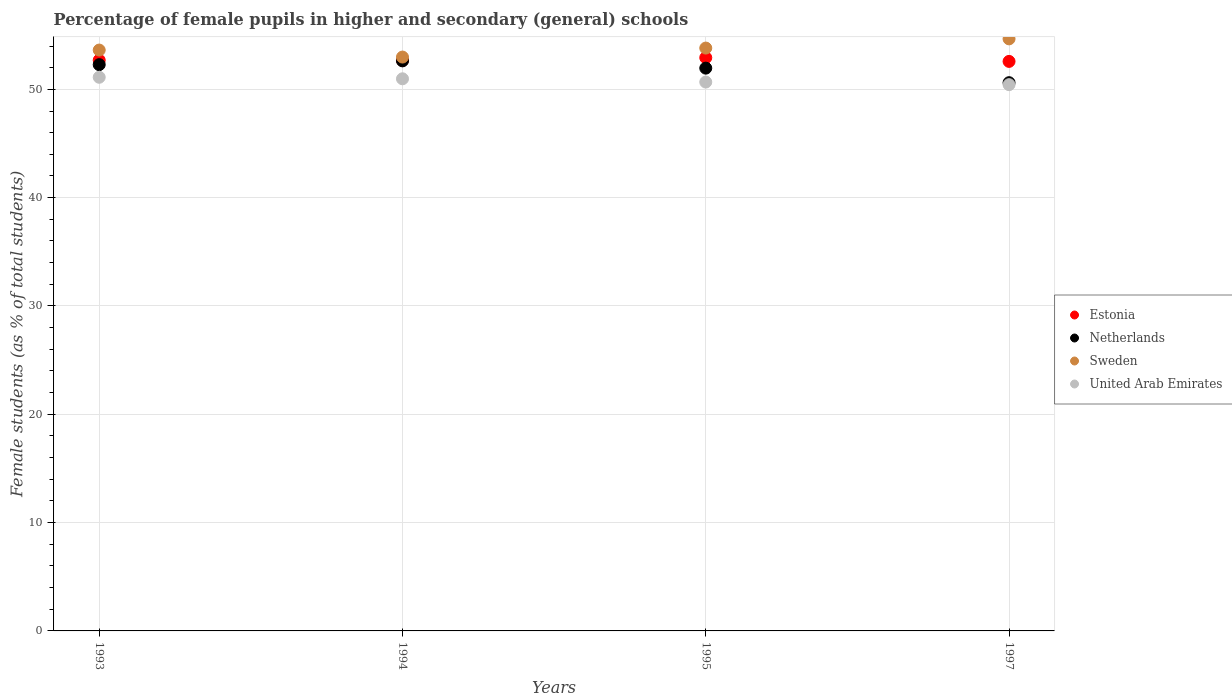Is the number of dotlines equal to the number of legend labels?
Make the answer very short. Yes. What is the percentage of female pupils in higher and secondary schools in Sweden in 1995?
Your answer should be compact. 53.81. Across all years, what is the maximum percentage of female pupils in higher and secondary schools in United Arab Emirates?
Offer a very short reply. 51.12. Across all years, what is the minimum percentage of female pupils in higher and secondary schools in Sweden?
Your answer should be compact. 52.98. In which year was the percentage of female pupils in higher and secondary schools in Sweden minimum?
Your answer should be very brief. 1994. What is the total percentage of female pupils in higher and secondary schools in Sweden in the graph?
Offer a very short reply. 215.08. What is the difference between the percentage of female pupils in higher and secondary schools in United Arab Emirates in 1994 and that in 1997?
Give a very brief answer. 0.54. What is the difference between the percentage of female pupils in higher and secondary schools in United Arab Emirates in 1993 and the percentage of female pupils in higher and secondary schools in Netherlands in 1995?
Ensure brevity in your answer.  -0.84. What is the average percentage of female pupils in higher and secondary schools in Estonia per year?
Make the answer very short. 52.72. In the year 1994, what is the difference between the percentage of female pupils in higher and secondary schools in Sweden and percentage of female pupils in higher and secondary schools in Estonia?
Provide a short and direct response. 0.3. What is the ratio of the percentage of female pupils in higher and secondary schools in Estonia in 1994 to that in 1997?
Make the answer very short. 1. Is the percentage of female pupils in higher and secondary schools in Estonia in 1993 less than that in 1994?
Ensure brevity in your answer.  No. Is the difference between the percentage of female pupils in higher and secondary schools in Sweden in 1993 and 1994 greater than the difference between the percentage of female pupils in higher and secondary schools in Estonia in 1993 and 1994?
Keep it short and to the point. Yes. What is the difference between the highest and the second highest percentage of female pupils in higher and secondary schools in Estonia?
Provide a succinct answer. 0.23. What is the difference between the highest and the lowest percentage of female pupils in higher and secondary schools in Sweden?
Your answer should be compact. 1.68. Is it the case that in every year, the sum of the percentage of female pupils in higher and secondary schools in Netherlands and percentage of female pupils in higher and secondary schools in Sweden  is greater than the sum of percentage of female pupils in higher and secondary schools in United Arab Emirates and percentage of female pupils in higher and secondary schools in Estonia?
Keep it short and to the point. No. Does the percentage of female pupils in higher and secondary schools in Netherlands monotonically increase over the years?
Offer a terse response. No. Is the percentage of female pupils in higher and secondary schools in Netherlands strictly greater than the percentage of female pupils in higher and secondary schools in United Arab Emirates over the years?
Provide a succinct answer. Yes. How many years are there in the graph?
Offer a very short reply. 4. What is the difference between two consecutive major ticks on the Y-axis?
Provide a succinct answer. 10. Are the values on the major ticks of Y-axis written in scientific E-notation?
Give a very brief answer. No. Does the graph contain any zero values?
Make the answer very short. No. Does the graph contain grids?
Your answer should be compact. Yes. Where does the legend appear in the graph?
Your answer should be very brief. Center right. What is the title of the graph?
Give a very brief answer. Percentage of female pupils in higher and secondary (general) schools. Does "Greenland" appear as one of the legend labels in the graph?
Keep it short and to the point. No. What is the label or title of the Y-axis?
Offer a terse response. Female students (as % of total students). What is the Female students (as % of total students) of Estonia in 1993?
Provide a short and direct response. 52.69. What is the Female students (as % of total students) of Netherlands in 1993?
Your answer should be compact. 52.28. What is the Female students (as % of total students) in Sweden in 1993?
Your answer should be compact. 53.63. What is the Female students (as % of total students) of United Arab Emirates in 1993?
Your answer should be compact. 51.12. What is the Female students (as % of total students) in Estonia in 1994?
Give a very brief answer. 52.68. What is the Female students (as % of total students) in Netherlands in 1994?
Ensure brevity in your answer.  52.63. What is the Female students (as % of total students) in Sweden in 1994?
Offer a terse response. 52.98. What is the Female students (as % of total students) in United Arab Emirates in 1994?
Offer a very short reply. 50.97. What is the Female students (as % of total students) in Estonia in 1995?
Your answer should be compact. 52.93. What is the Female students (as % of total students) of Netherlands in 1995?
Give a very brief answer. 51.96. What is the Female students (as % of total students) of Sweden in 1995?
Offer a very short reply. 53.81. What is the Female students (as % of total students) in United Arab Emirates in 1995?
Your answer should be compact. 50.67. What is the Female students (as % of total students) of Estonia in 1997?
Give a very brief answer. 52.58. What is the Female students (as % of total students) in Netherlands in 1997?
Provide a succinct answer. 50.62. What is the Female students (as % of total students) in Sweden in 1997?
Your response must be concise. 54.66. What is the Female students (as % of total students) of United Arab Emirates in 1997?
Offer a very short reply. 50.43. Across all years, what is the maximum Female students (as % of total students) of Estonia?
Keep it short and to the point. 52.93. Across all years, what is the maximum Female students (as % of total students) of Netherlands?
Provide a short and direct response. 52.63. Across all years, what is the maximum Female students (as % of total students) of Sweden?
Offer a terse response. 54.66. Across all years, what is the maximum Female students (as % of total students) of United Arab Emirates?
Offer a very short reply. 51.12. Across all years, what is the minimum Female students (as % of total students) of Estonia?
Offer a very short reply. 52.58. Across all years, what is the minimum Female students (as % of total students) of Netherlands?
Keep it short and to the point. 50.62. Across all years, what is the minimum Female students (as % of total students) of Sweden?
Keep it short and to the point. 52.98. Across all years, what is the minimum Female students (as % of total students) in United Arab Emirates?
Your response must be concise. 50.43. What is the total Female students (as % of total students) of Estonia in the graph?
Offer a terse response. 210.87. What is the total Female students (as % of total students) in Netherlands in the graph?
Provide a short and direct response. 207.48. What is the total Female students (as % of total students) in Sweden in the graph?
Offer a terse response. 215.08. What is the total Female students (as % of total students) in United Arab Emirates in the graph?
Your answer should be compact. 203.2. What is the difference between the Female students (as % of total students) of Estonia in 1993 and that in 1994?
Offer a very short reply. 0.01. What is the difference between the Female students (as % of total students) of Netherlands in 1993 and that in 1994?
Give a very brief answer. -0.35. What is the difference between the Female students (as % of total students) of Sweden in 1993 and that in 1994?
Make the answer very short. 0.65. What is the difference between the Female students (as % of total students) of United Arab Emirates in 1993 and that in 1994?
Make the answer very short. 0.14. What is the difference between the Female students (as % of total students) of Estonia in 1993 and that in 1995?
Ensure brevity in your answer.  -0.23. What is the difference between the Female students (as % of total students) in Netherlands in 1993 and that in 1995?
Ensure brevity in your answer.  0.32. What is the difference between the Female students (as % of total students) in Sweden in 1993 and that in 1995?
Offer a very short reply. -0.18. What is the difference between the Female students (as % of total students) of United Arab Emirates in 1993 and that in 1995?
Provide a succinct answer. 0.44. What is the difference between the Female students (as % of total students) of Estonia in 1993 and that in 1997?
Provide a short and direct response. 0.11. What is the difference between the Female students (as % of total students) of Netherlands in 1993 and that in 1997?
Give a very brief answer. 1.67. What is the difference between the Female students (as % of total students) in Sweden in 1993 and that in 1997?
Keep it short and to the point. -1.03. What is the difference between the Female students (as % of total students) in United Arab Emirates in 1993 and that in 1997?
Offer a very short reply. 0.68. What is the difference between the Female students (as % of total students) of Estonia in 1994 and that in 1995?
Ensure brevity in your answer.  -0.25. What is the difference between the Female students (as % of total students) of Netherlands in 1994 and that in 1995?
Your answer should be compact. 0.67. What is the difference between the Female students (as % of total students) in Sweden in 1994 and that in 1995?
Your answer should be compact. -0.83. What is the difference between the Female students (as % of total students) of United Arab Emirates in 1994 and that in 1995?
Offer a very short reply. 0.3. What is the difference between the Female students (as % of total students) of Estonia in 1994 and that in 1997?
Offer a very short reply. 0.1. What is the difference between the Female students (as % of total students) of Netherlands in 1994 and that in 1997?
Ensure brevity in your answer.  2.01. What is the difference between the Female students (as % of total students) of Sweden in 1994 and that in 1997?
Your answer should be compact. -1.68. What is the difference between the Female students (as % of total students) in United Arab Emirates in 1994 and that in 1997?
Your answer should be very brief. 0.54. What is the difference between the Female students (as % of total students) of Estonia in 1995 and that in 1997?
Give a very brief answer. 0.35. What is the difference between the Female students (as % of total students) in Netherlands in 1995 and that in 1997?
Your response must be concise. 1.34. What is the difference between the Female students (as % of total students) of Sweden in 1995 and that in 1997?
Your answer should be very brief. -0.85. What is the difference between the Female students (as % of total students) of United Arab Emirates in 1995 and that in 1997?
Your answer should be very brief. 0.24. What is the difference between the Female students (as % of total students) in Estonia in 1993 and the Female students (as % of total students) in Netherlands in 1994?
Give a very brief answer. 0.06. What is the difference between the Female students (as % of total students) in Estonia in 1993 and the Female students (as % of total students) in Sweden in 1994?
Ensure brevity in your answer.  -0.29. What is the difference between the Female students (as % of total students) in Estonia in 1993 and the Female students (as % of total students) in United Arab Emirates in 1994?
Make the answer very short. 1.72. What is the difference between the Female students (as % of total students) of Netherlands in 1993 and the Female students (as % of total students) of Sweden in 1994?
Offer a very short reply. -0.7. What is the difference between the Female students (as % of total students) in Netherlands in 1993 and the Female students (as % of total students) in United Arab Emirates in 1994?
Offer a terse response. 1.31. What is the difference between the Female students (as % of total students) of Sweden in 1993 and the Female students (as % of total students) of United Arab Emirates in 1994?
Provide a short and direct response. 2.65. What is the difference between the Female students (as % of total students) in Estonia in 1993 and the Female students (as % of total students) in Netherlands in 1995?
Your response must be concise. 0.73. What is the difference between the Female students (as % of total students) in Estonia in 1993 and the Female students (as % of total students) in Sweden in 1995?
Give a very brief answer. -1.12. What is the difference between the Female students (as % of total students) of Estonia in 1993 and the Female students (as % of total students) of United Arab Emirates in 1995?
Your response must be concise. 2.02. What is the difference between the Female students (as % of total students) of Netherlands in 1993 and the Female students (as % of total students) of Sweden in 1995?
Ensure brevity in your answer.  -1.53. What is the difference between the Female students (as % of total students) of Netherlands in 1993 and the Female students (as % of total students) of United Arab Emirates in 1995?
Provide a short and direct response. 1.61. What is the difference between the Female students (as % of total students) in Sweden in 1993 and the Female students (as % of total students) in United Arab Emirates in 1995?
Provide a succinct answer. 2.95. What is the difference between the Female students (as % of total students) in Estonia in 1993 and the Female students (as % of total students) in Netherlands in 1997?
Offer a terse response. 2.08. What is the difference between the Female students (as % of total students) of Estonia in 1993 and the Female students (as % of total students) of Sweden in 1997?
Keep it short and to the point. -1.97. What is the difference between the Female students (as % of total students) of Estonia in 1993 and the Female students (as % of total students) of United Arab Emirates in 1997?
Provide a succinct answer. 2.26. What is the difference between the Female students (as % of total students) in Netherlands in 1993 and the Female students (as % of total students) in Sweden in 1997?
Provide a short and direct response. -2.38. What is the difference between the Female students (as % of total students) in Netherlands in 1993 and the Female students (as % of total students) in United Arab Emirates in 1997?
Give a very brief answer. 1.85. What is the difference between the Female students (as % of total students) of Sweden in 1993 and the Female students (as % of total students) of United Arab Emirates in 1997?
Offer a terse response. 3.19. What is the difference between the Female students (as % of total students) of Estonia in 1994 and the Female students (as % of total students) of Netherlands in 1995?
Keep it short and to the point. 0.72. What is the difference between the Female students (as % of total students) of Estonia in 1994 and the Female students (as % of total students) of Sweden in 1995?
Your response must be concise. -1.13. What is the difference between the Female students (as % of total students) in Estonia in 1994 and the Female students (as % of total students) in United Arab Emirates in 1995?
Give a very brief answer. 2. What is the difference between the Female students (as % of total students) of Netherlands in 1994 and the Female students (as % of total students) of Sweden in 1995?
Give a very brief answer. -1.18. What is the difference between the Female students (as % of total students) in Netherlands in 1994 and the Female students (as % of total students) in United Arab Emirates in 1995?
Your answer should be compact. 1.96. What is the difference between the Female students (as % of total students) of Sweden in 1994 and the Female students (as % of total students) of United Arab Emirates in 1995?
Keep it short and to the point. 2.31. What is the difference between the Female students (as % of total students) in Estonia in 1994 and the Female students (as % of total students) in Netherlands in 1997?
Your answer should be very brief. 2.06. What is the difference between the Female students (as % of total students) in Estonia in 1994 and the Female students (as % of total students) in Sweden in 1997?
Provide a succinct answer. -1.98. What is the difference between the Female students (as % of total students) in Estonia in 1994 and the Female students (as % of total students) in United Arab Emirates in 1997?
Provide a short and direct response. 2.24. What is the difference between the Female students (as % of total students) in Netherlands in 1994 and the Female students (as % of total students) in Sweden in 1997?
Your answer should be very brief. -2.03. What is the difference between the Female students (as % of total students) of Netherlands in 1994 and the Female students (as % of total students) of United Arab Emirates in 1997?
Give a very brief answer. 2.2. What is the difference between the Female students (as % of total students) of Sweden in 1994 and the Female students (as % of total students) of United Arab Emirates in 1997?
Your answer should be very brief. 2.55. What is the difference between the Female students (as % of total students) in Estonia in 1995 and the Female students (as % of total students) in Netherlands in 1997?
Keep it short and to the point. 2.31. What is the difference between the Female students (as % of total students) of Estonia in 1995 and the Female students (as % of total students) of Sweden in 1997?
Your answer should be very brief. -1.74. What is the difference between the Female students (as % of total students) of Estonia in 1995 and the Female students (as % of total students) of United Arab Emirates in 1997?
Provide a succinct answer. 2.49. What is the difference between the Female students (as % of total students) in Netherlands in 1995 and the Female students (as % of total students) in Sweden in 1997?
Keep it short and to the point. -2.7. What is the difference between the Female students (as % of total students) of Netherlands in 1995 and the Female students (as % of total students) of United Arab Emirates in 1997?
Provide a short and direct response. 1.52. What is the difference between the Female students (as % of total students) in Sweden in 1995 and the Female students (as % of total students) in United Arab Emirates in 1997?
Ensure brevity in your answer.  3.38. What is the average Female students (as % of total students) in Estonia per year?
Your answer should be very brief. 52.72. What is the average Female students (as % of total students) in Netherlands per year?
Offer a very short reply. 51.87. What is the average Female students (as % of total students) in Sweden per year?
Ensure brevity in your answer.  53.77. What is the average Female students (as % of total students) of United Arab Emirates per year?
Your answer should be compact. 50.8. In the year 1993, what is the difference between the Female students (as % of total students) of Estonia and Female students (as % of total students) of Netherlands?
Your answer should be compact. 0.41. In the year 1993, what is the difference between the Female students (as % of total students) of Estonia and Female students (as % of total students) of Sweden?
Offer a terse response. -0.94. In the year 1993, what is the difference between the Female students (as % of total students) in Estonia and Female students (as % of total students) in United Arab Emirates?
Provide a succinct answer. 1.58. In the year 1993, what is the difference between the Female students (as % of total students) in Netherlands and Female students (as % of total students) in Sweden?
Your answer should be very brief. -1.35. In the year 1993, what is the difference between the Female students (as % of total students) in Netherlands and Female students (as % of total students) in United Arab Emirates?
Keep it short and to the point. 1.17. In the year 1993, what is the difference between the Female students (as % of total students) in Sweden and Female students (as % of total students) in United Arab Emirates?
Make the answer very short. 2.51. In the year 1994, what is the difference between the Female students (as % of total students) of Estonia and Female students (as % of total students) of Netherlands?
Provide a succinct answer. 0.05. In the year 1994, what is the difference between the Female students (as % of total students) of Estonia and Female students (as % of total students) of Sweden?
Give a very brief answer. -0.3. In the year 1994, what is the difference between the Female students (as % of total students) in Estonia and Female students (as % of total students) in United Arab Emirates?
Offer a terse response. 1.7. In the year 1994, what is the difference between the Female students (as % of total students) in Netherlands and Female students (as % of total students) in Sweden?
Offer a very short reply. -0.35. In the year 1994, what is the difference between the Female students (as % of total students) in Netherlands and Female students (as % of total students) in United Arab Emirates?
Provide a short and direct response. 1.66. In the year 1994, what is the difference between the Female students (as % of total students) in Sweden and Female students (as % of total students) in United Arab Emirates?
Give a very brief answer. 2.01. In the year 1995, what is the difference between the Female students (as % of total students) of Estonia and Female students (as % of total students) of Netherlands?
Offer a very short reply. 0.97. In the year 1995, what is the difference between the Female students (as % of total students) of Estonia and Female students (as % of total students) of Sweden?
Keep it short and to the point. -0.89. In the year 1995, what is the difference between the Female students (as % of total students) in Estonia and Female students (as % of total students) in United Arab Emirates?
Ensure brevity in your answer.  2.25. In the year 1995, what is the difference between the Female students (as % of total students) in Netherlands and Female students (as % of total students) in Sweden?
Your answer should be very brief. -1.85. In the year 1995, what is the difference between the Female students (as % of total students) of Netherlands and Female students (as % of total students) of United Arab Emirates?
Make the answer very short. 1.28. In the year 1995, what is the difference between the Female students (as % of total students) of Sweden and Female students (as % of total students) of United Arab Emirates?
Ensure brevity in your answer.  3.14. In the year 1997, what is the difference between the Female students (as % of total students) of Estonia and Female students (as % of total students) of Netherlands?
Provide a succinct answer. 1.96. In the year 1997, what is the difference between the Female students (as % of total students) of Estonia and Female students (as % of total students) of Sweden?
Ensure brevity in your answer.  -2.08. In the year 1997, what is the difference between the Female students (as % of total students) of Estonia and Female students (as % of total students) of United Arab Emirates?
Ensure brevity in your answer.  2.15. In the year 1997, what is the difference between the Female students (as % of total students) of Netherlands and Female students (as % of total students) of Sweden?
Offer a terse response. -4.05. In the year 1997, what is the difference between the Female students (as % of total students) of Netherlands and Female students (as % of total students) of United Arab Emirates?
Your response must be concise. 0.18. In the year 1997, what is the difference between the Female students (as % of total students) in Sweden and Female students (as % of total students) in United Arab Emirates?
Offer a terse response. 4.23. What is the ratio of the Female students (as % of total students) of Sweden in 1993 to that in 1994?
Keep it short and to the point. 1.01. What is the ratio of the Female students (as % of total students) of United Arab Emirates in 1993 to that in 1994?
Offer a terse response. 1. What is the ratio of the Female students (as % of total students) in Sweden in 1993 to that in 1995?
Keep it short and to the point. 1. What is the ratio of the Female students (as % of total students) of United Arab Emirates in 1993 to that in 1995?
Keep it short and to the point. 1.01. What is the ratio of the Female students (as % of total students) in Netherlands in 1993 to that in 1997?
Offer a terse response. 1.03. What is the ratio of the Female students (as % of total students) of Sweden in 1993 to that in 1997?
Give a very brief answer. 0.98. What is the ratio of the Female students (as % of total students) of United Arab Emirates in 1993 to that in 1997?
Your response must be concise. 1.01. What is the ratio of the Female students (as % of total students) of Estonia in 1994 to that in 1995?
Make the answer very short. 1. What is the ratio of the Female students (as % of total students) in Netherlands in 1994 to that in 1995?
Offer a very short reply. 1.01. What is the ratio of the Female students (as % of total students) in Sweden in 1994 to that in 1995?
Offer a terse response. 0.98. What is the ratio of the Female students (as % of total students) in United Arab Emirates in 1994 to that in 1995?
Your response must be concise. 1.01. What is the ratio of the Female students (as % of total students) in Netherlands in 1994 to that in 1997?
Offer a very short reply. 1.04. What is the ratio of the Female students (as % of total students) in Sweden in 1994 to that in 1997?
Ensure brevity in your answer.  0.97. What is the ratio of the Female students (as % of total students) of United Arab Emirates in 1994 to that in 1997?
Make the answer very short. 1.01. What is the ratio of the Female students (as % of total students) in Estonia in 1995 to that in 1997?
Give a very brief answer. 1.01. What is the ratio of the Female students (as % of total students) of Netherlands in 1995 to that in 1997?
Provide a succinct answer. 1.03. What is the ratio of the Female students (as % of total students) in Sweden in 1995 to that in 1997?
Make the answer very short. 0.98. What is the ratio of the Female students (as % of total students) in United Arab Emirates in 1995 to that in 1997?
Offer a very short reply. 1. What is the difference between the highest and the second highest Female students (as % of total students) in Estonia?
Offer a terse response. 0.23. What is the difference between the highest and the second highest Female students (as % of total students) of Netherlands?
Provide a short and direct response. 0.35. What is the difference between the highest and the second highest Female students (as % of total students) in Sweden?
Keep it short and to the point. 0.85. What is the difference between the highest and the second highest Female students (as % of total students) of United Arab Emirates?
Provide a succinct answer. 0.14. What is the difference between the highest and the lowest Female students (as % of total students) in Estonia?
Your answer should be compact. 0.35. What is the difference between the highest and the lowest Female students (as % of total students) in Netherlands?
Offer a very short reply. 2.01. What is the difference between the highest and the lowest Female students (as % of total students) in Sweden?
Offer a very short reply. 1.68. What is the difference between the highest and the lowest Female students (as % of total students) in United Arab Emirates?
Offer a terse response. 0.68. 